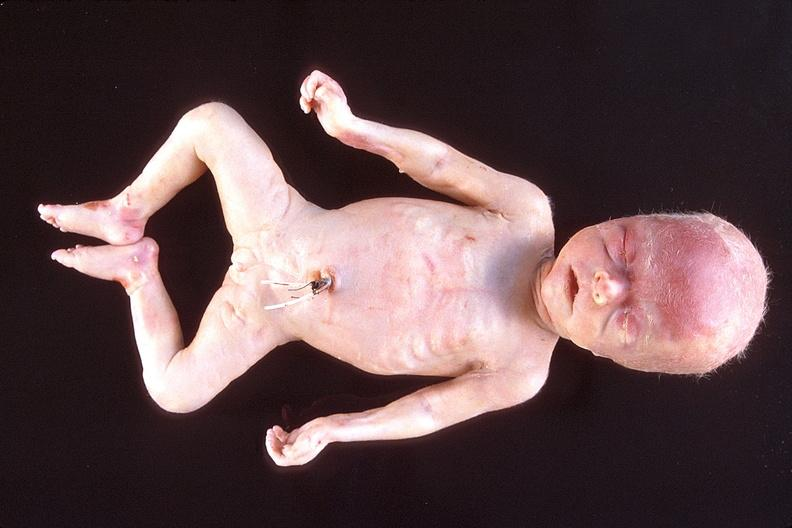what does this image show?
Answer the question using a single word or phrase. Hyaline membrane disease 